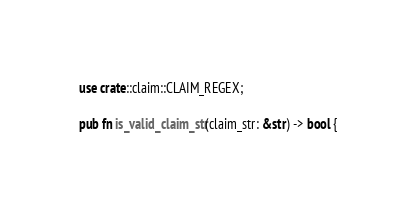Convert code to text. <code><loc_0><loc_0><loc_500><loc_500><_Rust_>use crate::claim::CLAIM_REGEX;

pub fn is_valid_claim_str(claim_str: &str) -> bool {</code> 